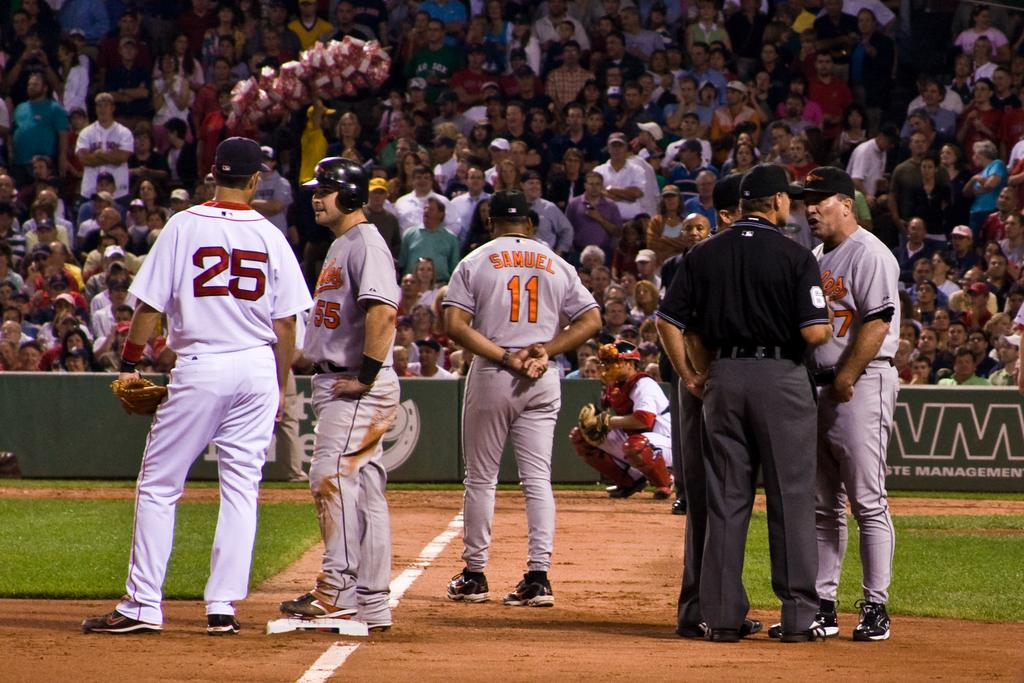<image>
Share a concise interpretation of the image provided. a person that has the number 11 on the back 